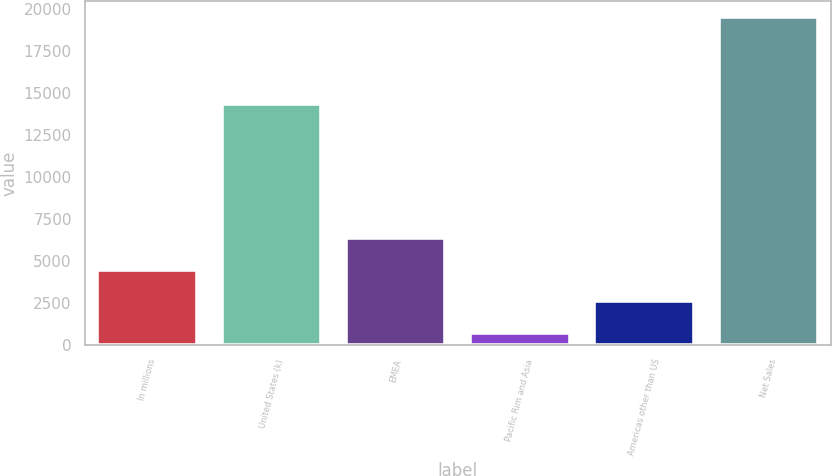<chart> <loc_0><loc_0><loc_500><loc_500><bar_chart><fcel>In millions<fcel>United States (k)<fcel>EMEA<fcel>Pacific Rim and Asia<fcel>Americas other than US<fcel>Net Sales<nl><fcel>4458.2<fcel>14363<fcel>6337.8<fcel>699<fcel>2578.6<fcel>19495<nl></chart> 